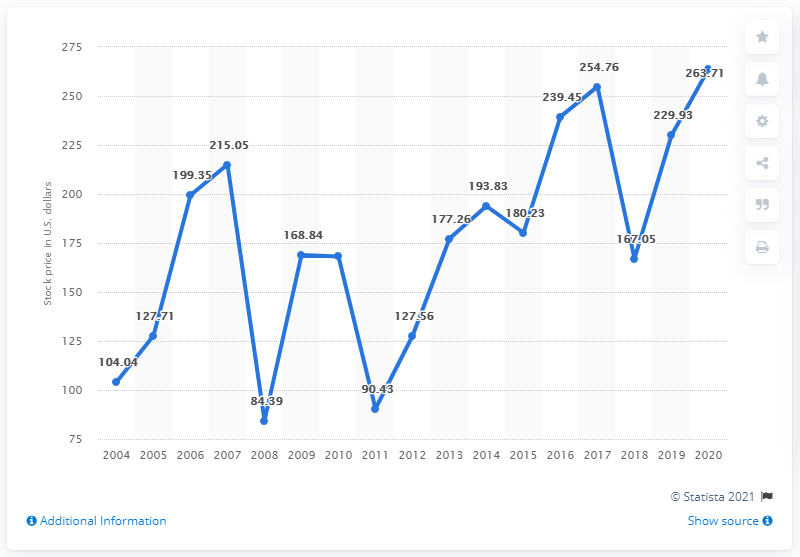Highlight a few significant elements in this photo. The difference between the highest and lowest stock price of Goldman Sachs between the years 2004 and 2020 was $179.32 in terms of U.S. dollars. As of 2013, the stock price of Goldman Sachs was $177.26 in U.S. dollars. In 2018, the stock price of Goldman Sachs reached its peak. 